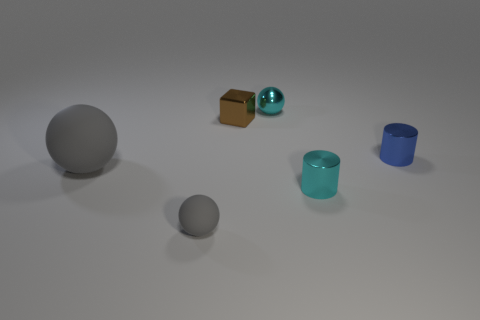Add 2 tiny cyan shiny spheres. How many objects exist? 8 Subtract all blocks. How many objects are left? 5 Add 2 red shiny things. How many red shiny things exist? 2 Subtract 0 yellow blocks. How many objects are left? 6 Subtract all tiny cyan metal spheres. Subtract all small cyan shiny cylinders. How many objects are left? 4 Add 5 tiny cyan cylinders. How many tiny cyan cylinders are left? 6 